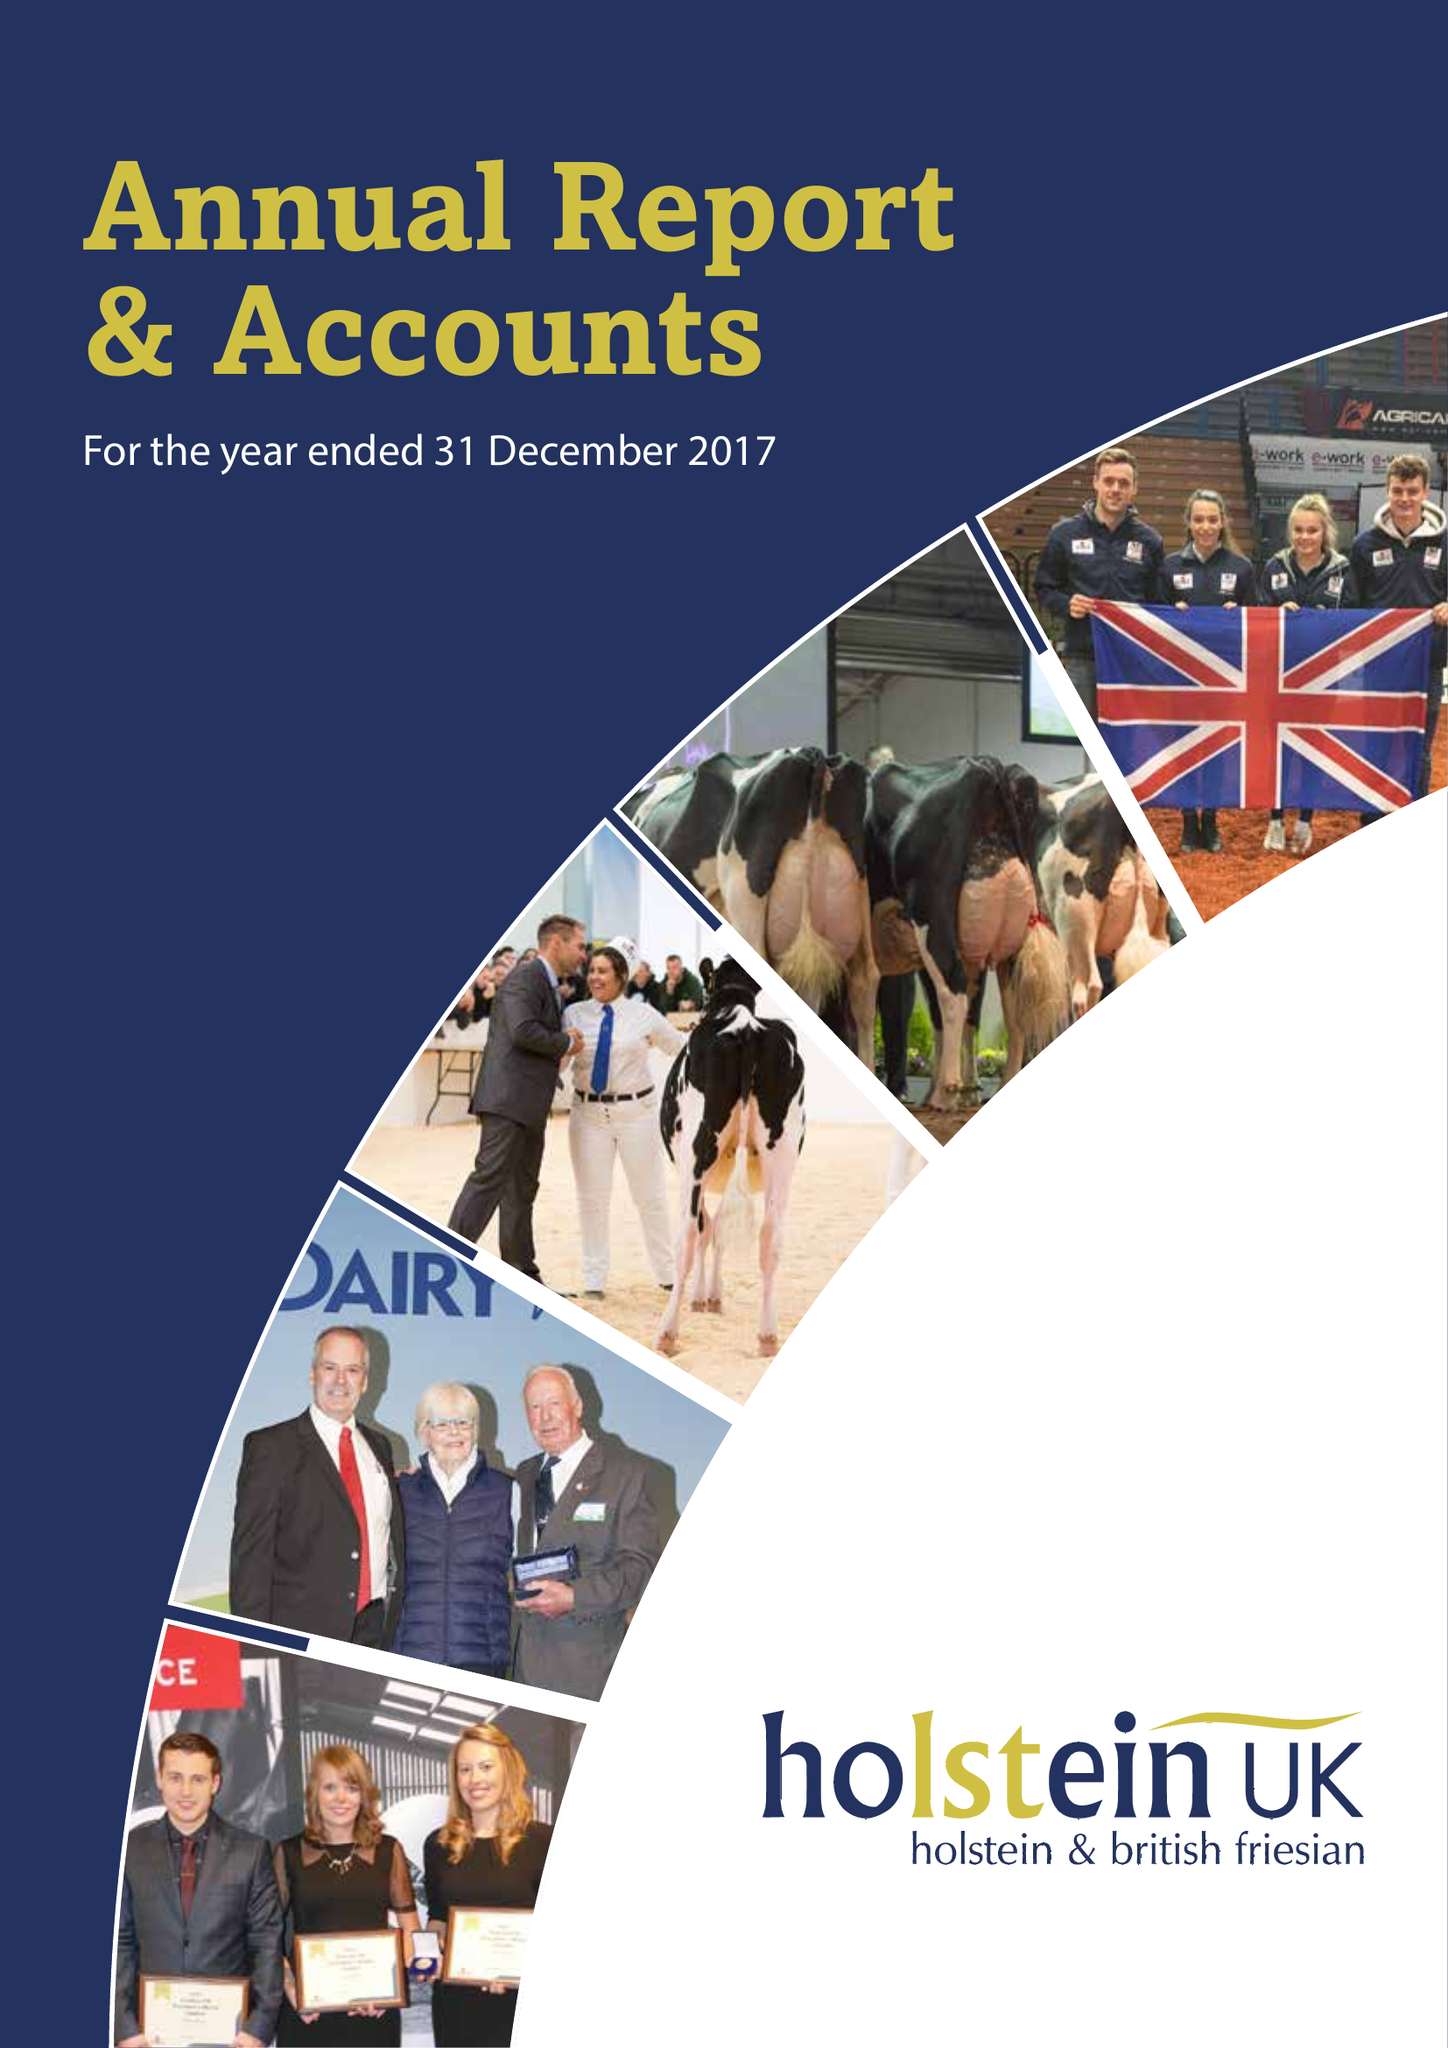What is the value for the income_annually_in_british_pounds?
Answer the question using a single word or phrase. 10328593.00 